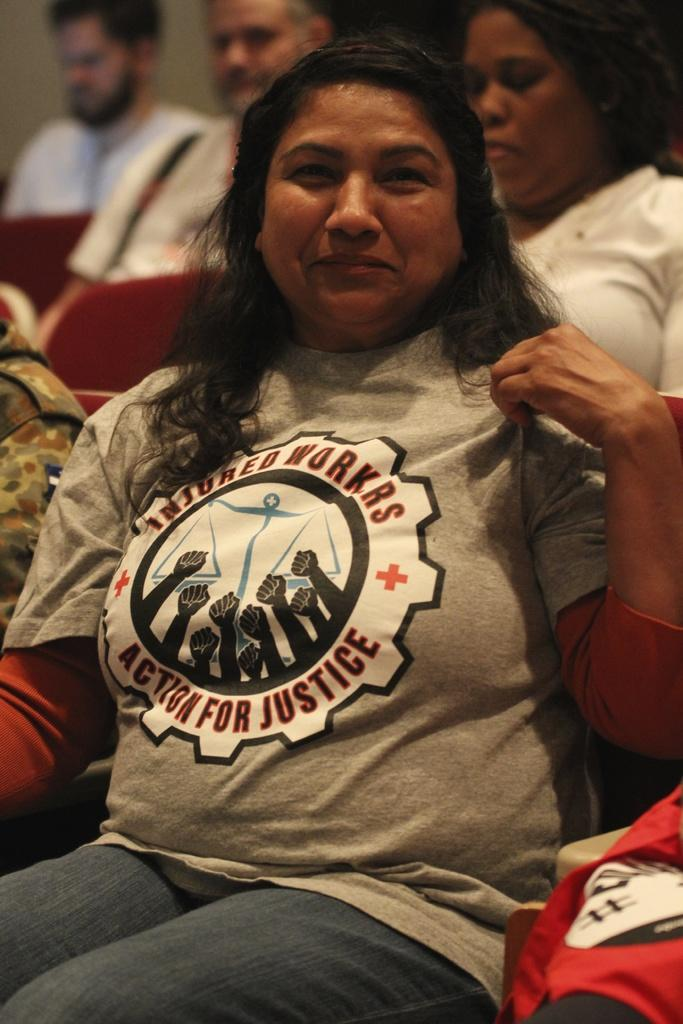<image>
Give a short and clear explanation of the subsequent image. A woman wears a t-shirt with the logo for Insured Workers Action for Justice. 